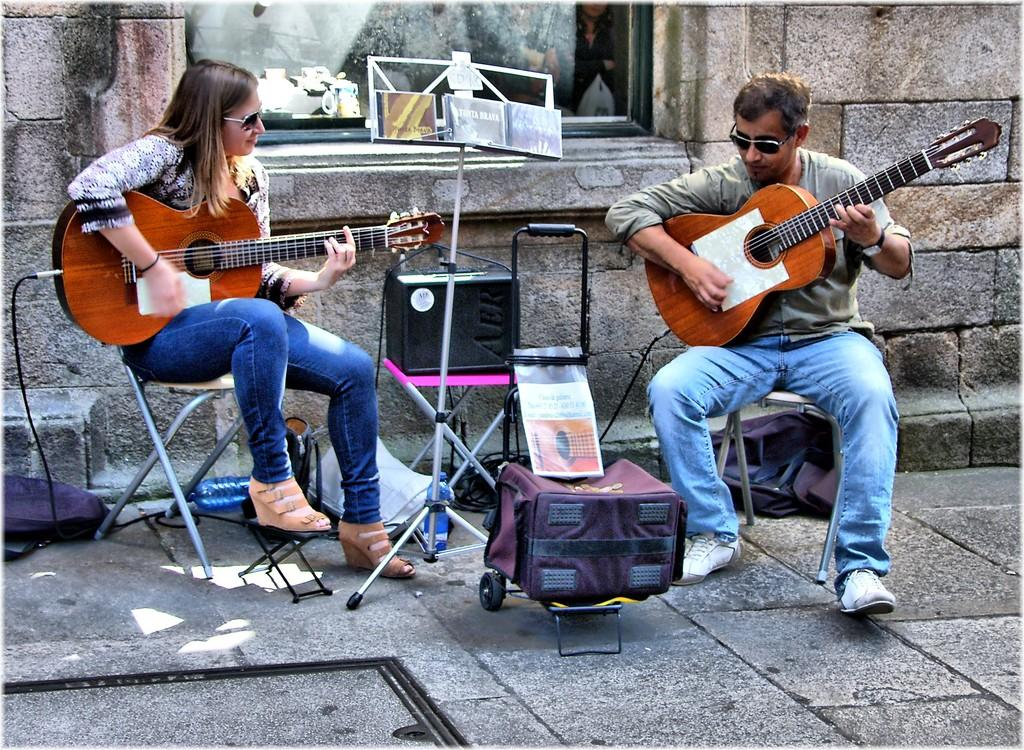How many people are in the image? There are two people in the image, a woman and a man. What are the woman and the man doing in the image? Both the woman and the man are playing guitar in the image. What are they sitting on while playing guitar? They are sitting on chairs. What is the birth date of the woman in the image? There is no information about the birth date of the woman in the image. 